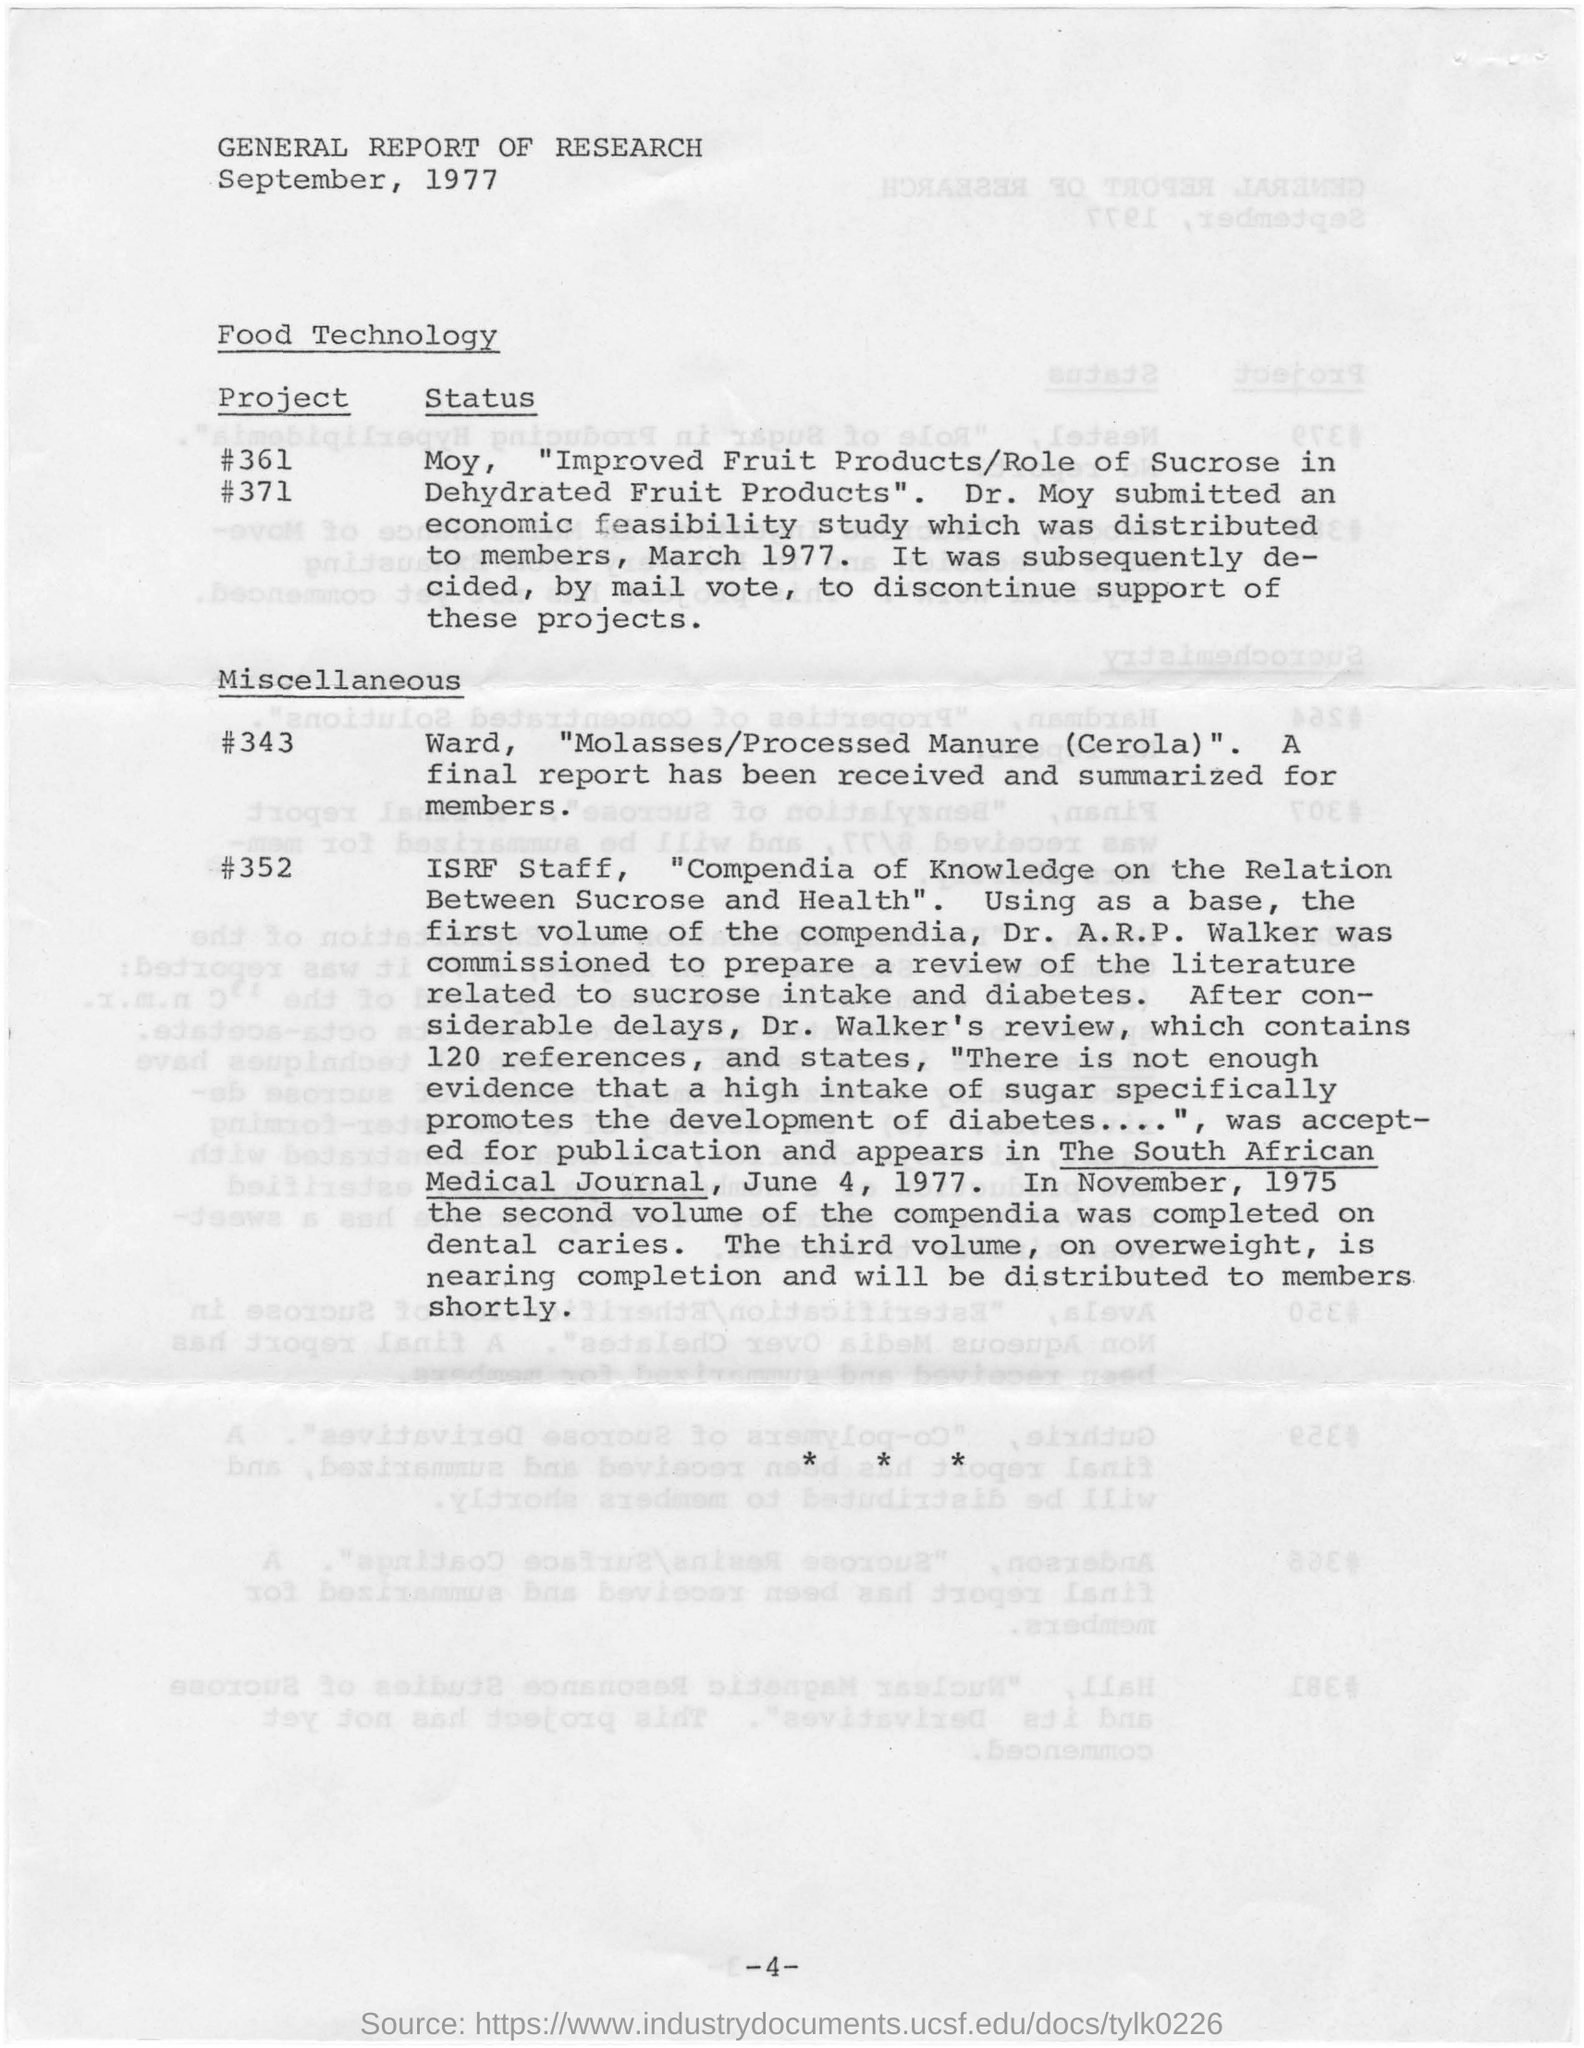When is the report dated?
Give a very brief answer. September, 1977. What is the document about?
Ensure brevity in your answer.  GENERAL REPORT OF RESEARCH. 